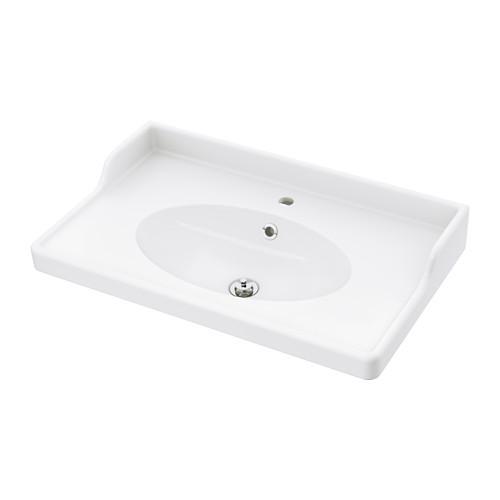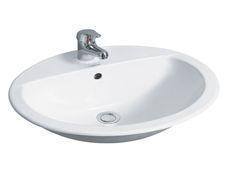The first image is the image on the left, the second image is the image on the right. Given the left and right images, does the statement "The sink in the image on the left is set into a counter." hold true? Answer yes or no. No. 